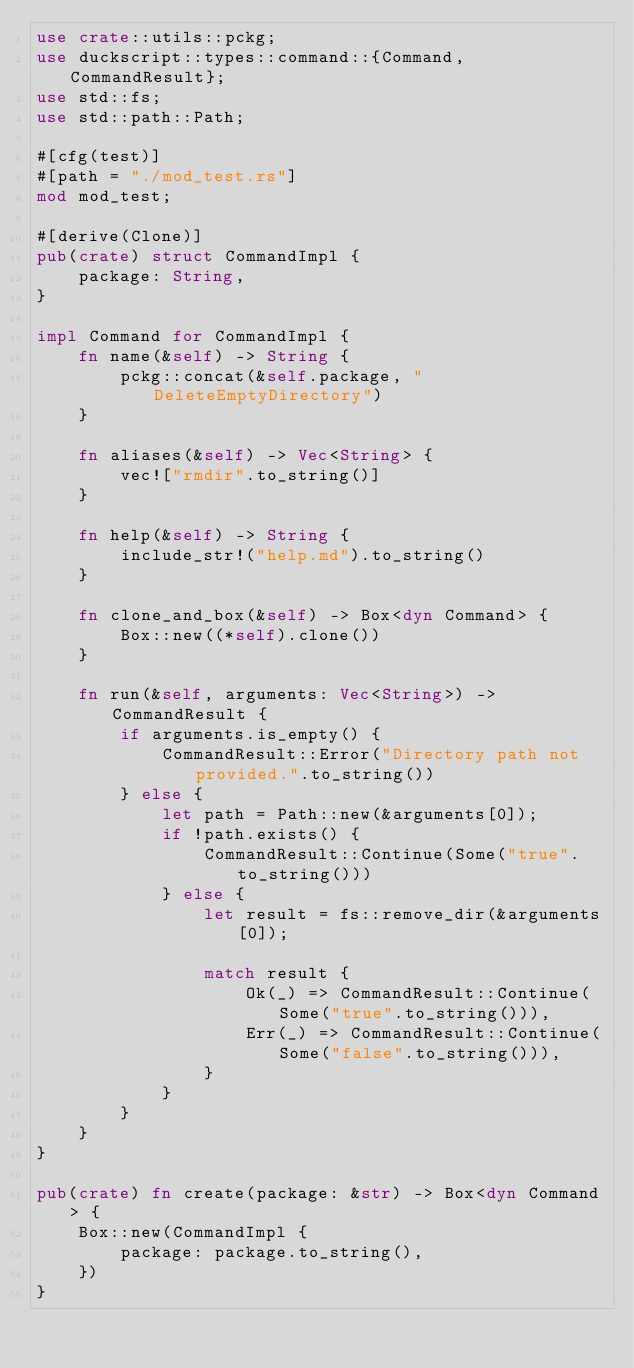Convert code to text. <code><loc_0><loc_0><loc_500><loc_500><_Rust_>use crate::utils::pckg;
use duckscript::types::command::{Command, CommandResult};
use std::fs;
use std::path::Path;

#[cfg(test)]
#[path = "./mod_test.rs"]
mod mod_test;

#[derive(Clone)]
pub(crate) struct CommandImpl {
    package: String,
}

impl Command for CommandImpl {
    fn name(&self) -> String {
        pckg::concat(&self.package, "DeleteEmptyDirectory")
    }

    fn aliases(&self) -> Vec<String> {
        vec!["rmdir".to_string()]
    }

    fn help(&self) -> String {
        include_str!("help.md").to_string()
    }

    fn clone_and_box(&self) -> Box<dyn Command> {
        Box::new((*self).clone())
    }

    fn run(&self, arguments: Vec<String>) -> CommandResult {
        if arguments.is_empty() {
            CommandResult::Error("Directory path not provided.".to_string())
        } else {
            let path = Path::new(&arguments[0]);
            if !path.exists() {
                CommandResult::Continue(Some("true".to_string()))
            } else {
                let result = fs::remove_dir(&arguments[0]);

                match result {
                    Ok(_) => CommandResult::Continue(Some("true".to_string())),
                    Err(_) => CommandResult::Continue(Some("false".to_string())),
                }
            }
        }
    }
}

pub(crate) fn create(package: &str) -> Box<dyn Command> {
    Box::new(CommandImpl {
        package: package.to_string(),
    })
}
</code> 